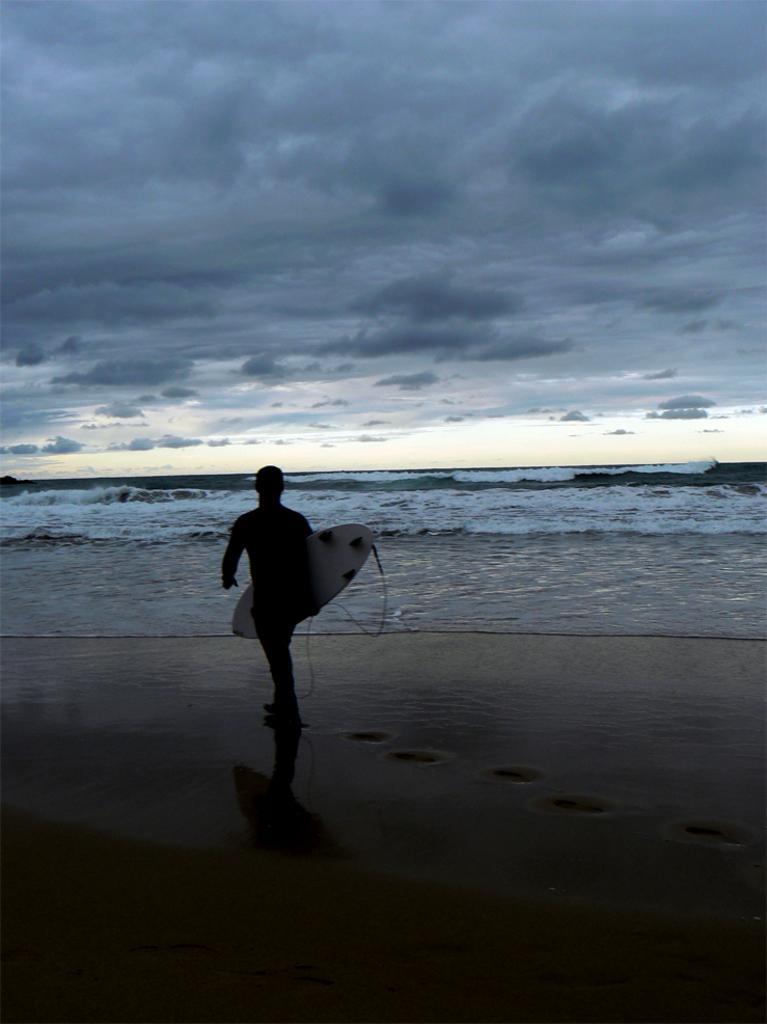Can you describe this image briefly? In this image I can see a person holding something. In the background, I can see the water and clouds in the sky. 